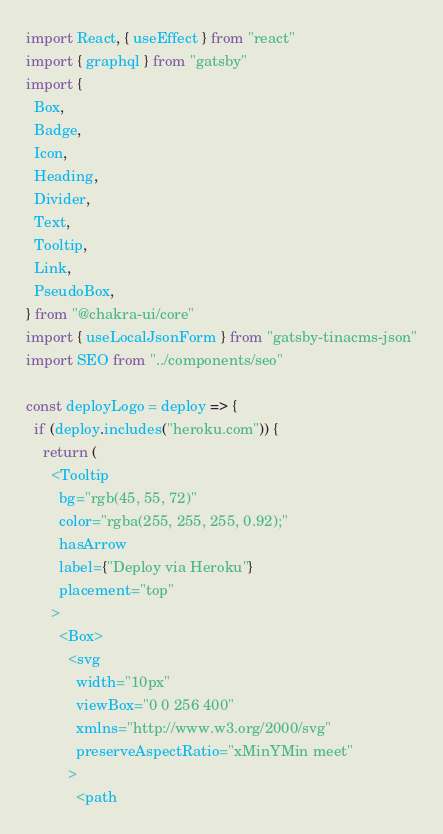<code> <loc_0><loc_0><loc_500><loc_500><_JavaScript_>import React, { useEffect } from "react"
import { graphql } from "gatsby"
import {
  Box,
  Badge,
  Icon,
  Heading,
  Divider,
  Text,
  Tooltip,
  Link,
  PseudoBox,
} from "@chakra-ui/core"
import { useLocalJsonForm } from "gatsby-tinacms-json"
import SEO from "../components/seo"

const deployLogo = deploy => {
  if (deploy.includes("heroku.com")) {
    return (
      <Tooltip
        bg="rgb(45, 55, 72)"
        color="rgba(255, 255, 255, 0.92);"
        hasArrow
        label={"Deploy via Heroku"}
        placement="top"
      >
        <Box>
          <svg
            width="10px"
            viewBox="0 0 256 400"
            xmlns="http://www.w3.org/2000/svg"
            preserveAspectRatio="xMinYMin meet"
          >
            <path</code> 